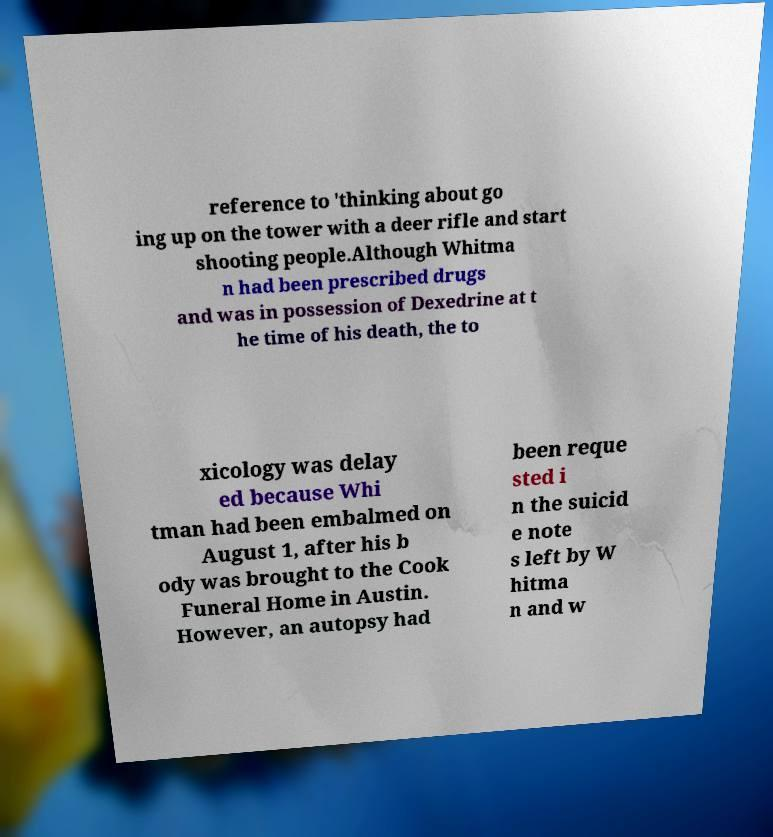Can you accurately transcribe the text from the provided image for me? reference to 'thinking about go ing up on the tower with a deer rifle and start shooting people.Although Whitma n had been prescribed drugs and was in possession of Dexedrine at t he time of his death, the to xicology was delay ed because Whi tman had been embalmed on August 1, after his b ody was brought to the Cook Funeral Home in Austin. However, an autopsy had been reque sted i n the suicid e note s left by W hitma n and w 